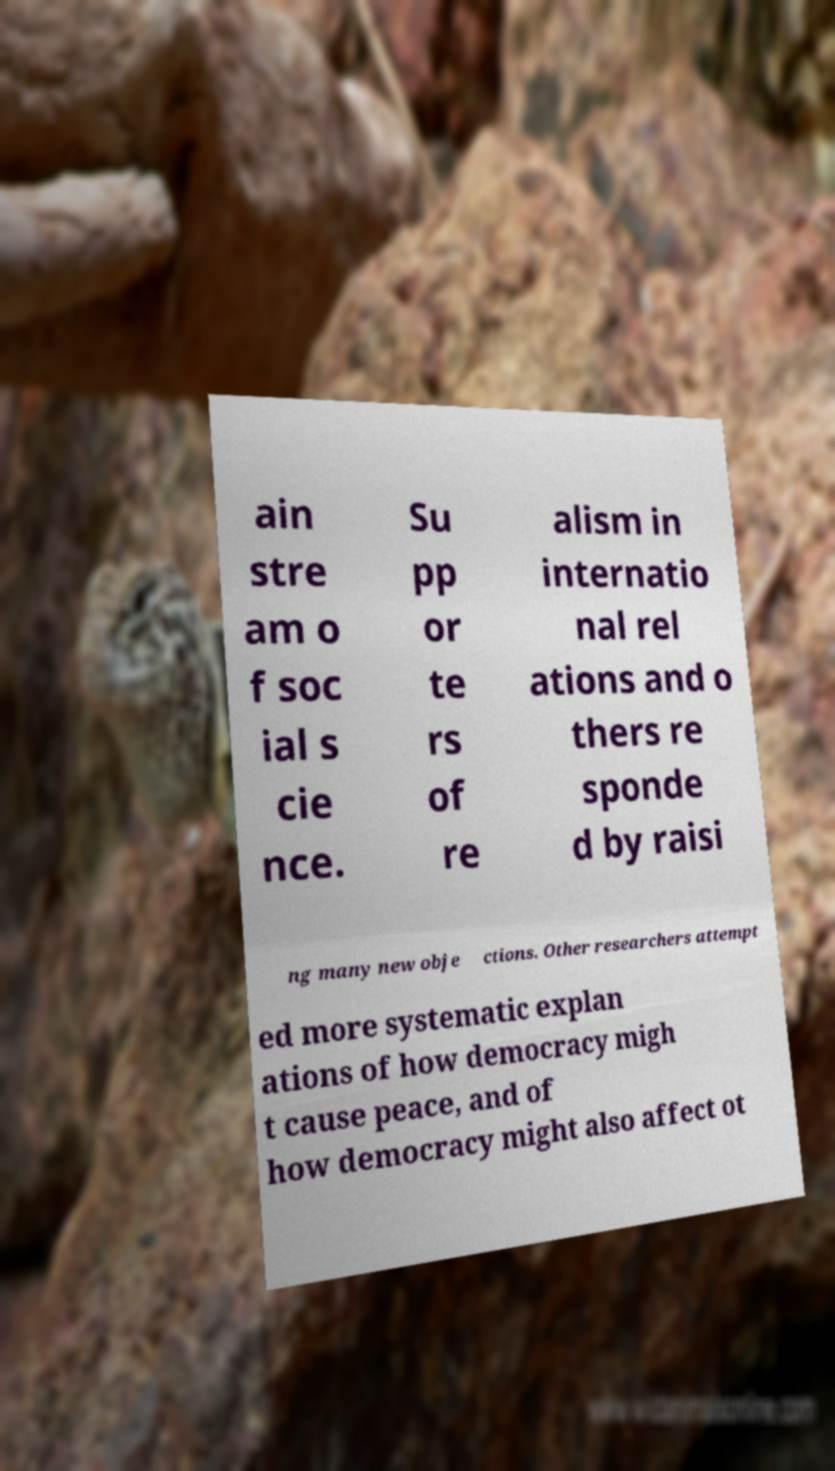Please read and relay the text visible in this image. What does it say? ain stre am o f soc ial s cie nce. Su pp or te rs of re alism in internatio nal rel ations and o thers re sponde d by raisi ng many new obje ctions. Other researchers attempt ed more systematic explan ations of how democracy migh t cause peace, and of how democracy might also affect ot 